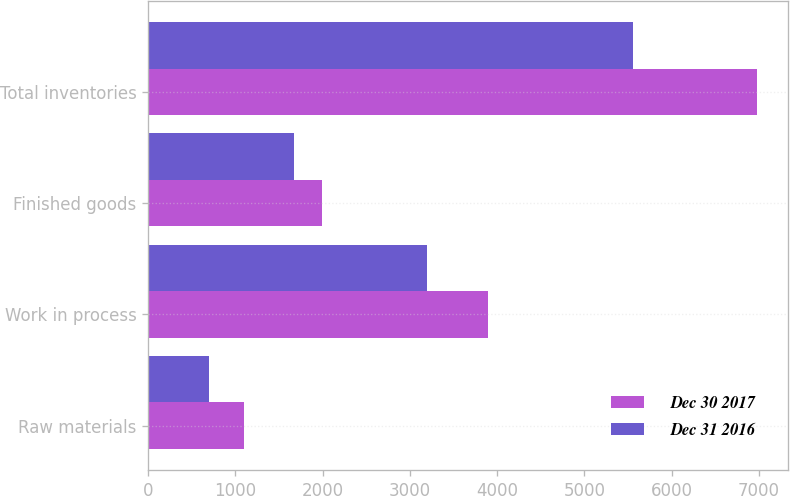<chart> <loc_0><loc_0><loc_500><loc_500><stacked_bar_chart><ecel><fcel>Raw materials<fcel>Work in process<fcel>Finished goods<fcel>Total inventories<nl><fcel>Dec 30 2017<fcel>1098<fcel>3893<fcel>1992<fcel>6983<nl><fcel>Dec 31 2016<fcel>695<fcel>3190<fcel>1668<fcel>5553<nl></chart> 